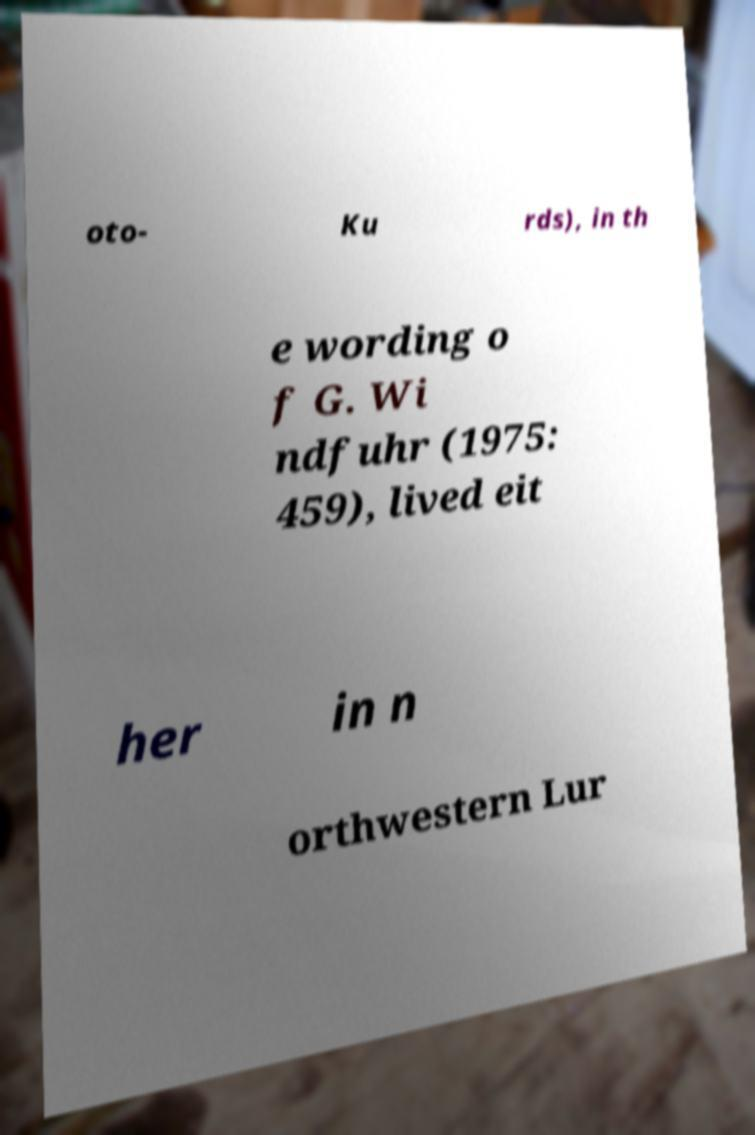Could you assist in decoding the text presented in this image and type it out clearly? oto- Ku rds), in th e wording o f G. Wi ndfuhr (1975: 459), lived eit her in n orthwestern Lur 